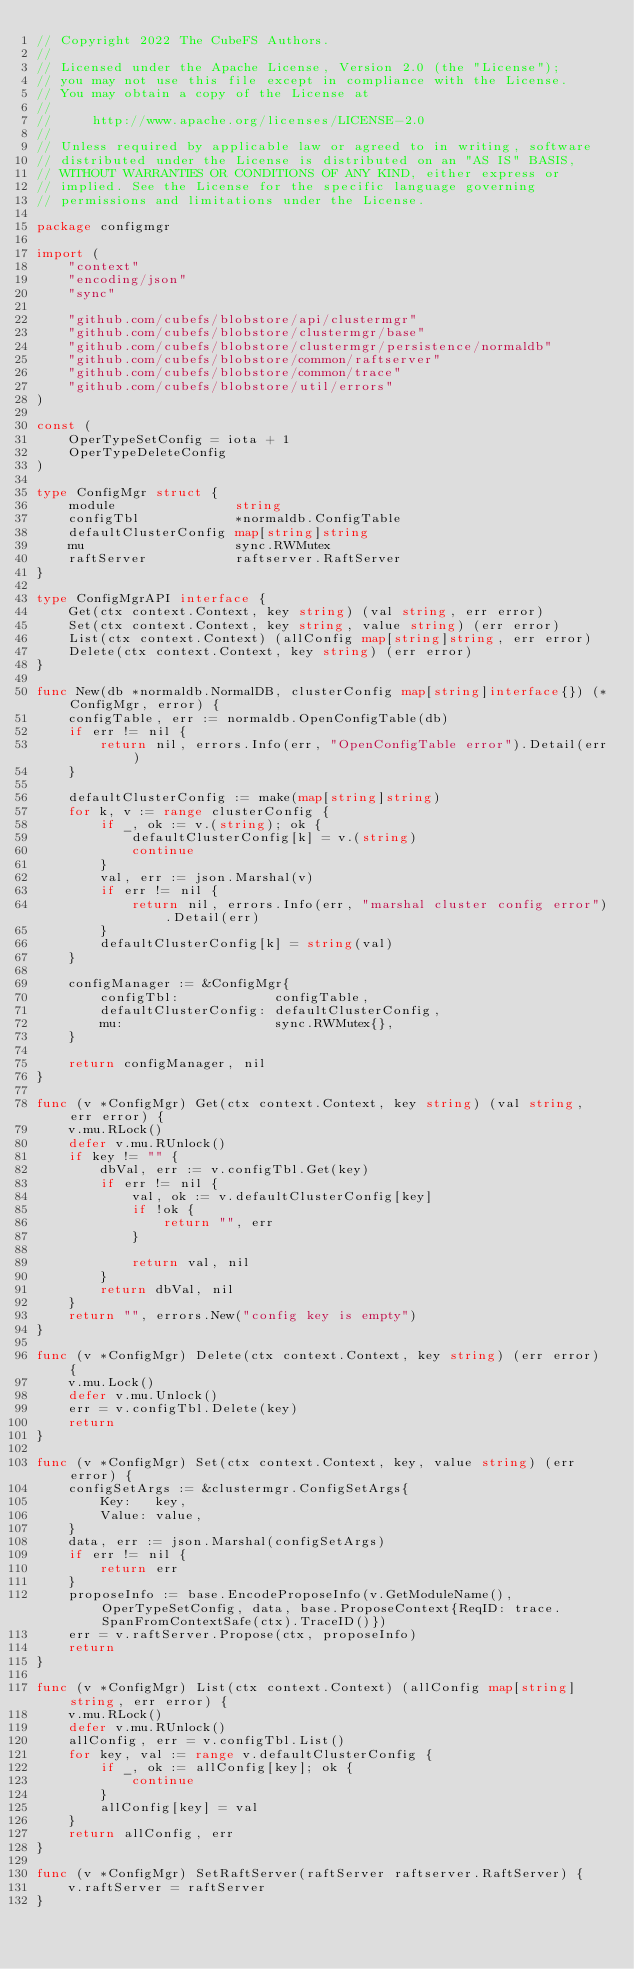Convert code to text. <code><loc_0><loc_0><loc_500><loc_500><_Go_>// Copyright 2022 The CubeFS Authors.
//
// Licensed under the Apache License, Version 2.0 (the "License");
// you may not use this file except in compliance with the License.
// You may obtain a copy of the License at
//
//     http://www.apache.org/licenses/LICENSE-2.0
//
// Unless required by applicable law or agreed to in writing, software
// distributed under the License is distributed on an "AS IS" BASIS,
// WITHOUT WARRANTIES OR CONDITIONS OF ANY KIND, either express or
// implied. See the License for the specific language governing
// permissions and limitations under the License.

package configmgr

import (
	"context"
	"encoding/json"
	"sync"

	"github.com/cubefs/blobstore/api/clustermgr"
	"github.com/cubefs/blobstore/clustermgr/base"
	"github.com/cubefs/blobstore/clustermgr/persistence/normaldb"
	"github.com/cubefs/blobstore/common/raftserver"
	"github.com/cubefs/blobstore/common/trace"
	"github.com/cubefs/blobstore/util/errors"
)

const (
	OperTypeSetConfig = iota + 1
	OperTypeDeleteConfig
)

type ConfigMgr struct {
	module               string
	configTbl            *normaldb.ConfigTable
	defaultClusterConfig map[string]string
	mu                   sync.RWMutex
	raftServer           raftserver.RaftServer
}

type ConfigMgrAPI interface {
	Get(ctx context.Context, key string) (val string, err error)
	Set(ctx context.Context, key string, value string) (err error)
	List(ctx context.Context) (allConfig map[string]string, err error)
	Delete(ctx context.Context, key string) (err error)
}

func New(db *normaldb.NormalDB, clusterConfig map[string]interface{}) (*ConfigMgr, error) {
	configTable, err := normaldb.OpenConfigTable(db)
	if err != nil {
		return nil, errors.Info(err, "OpenConfigTable error").Detail(err)
	}

	defaultClusterConfig := make(map[string]string)
	for k, v := range clusterConfig {
		if _, ok := v.(string); ok {
			defaultClusterConfig[k] = v.(string)
			continue
		}
		val, err := json.Marshal(v)
		if err != nil {
			return nil, errors.Info(err, "marshal cluster config error").Detail(err)
		}
		defaultClusterConfig[k] = string(val)
	}

	configManager := &ConfigMgr{
		configTbl:            configTable,
		defaultClusterConfig: defaultClusterConfig,
		mu:                   sync.RWMutex{},
	}

	return configManager, nil
}

func (v *ConfigMgr) Get(ctx context.Context, key string) (val string, err error) {
	v.mu.RLock()
	defer v.mu.RUnlock()
	if key != "" {
		dbVal, err := v.configTbl.Get(key)
		if err != nil {
			val, ok := v.defaultClusterConfig[key]
			if !ok {
				return "", err
			}

			return val, nil
		}
		return dbVal, nil
	}
	return "", errors.New("config key is empty")
}

func (v *ConfigMgr) Delete(ctx context.Context, key string) (err error) {
	v.mu.Lock()
	defer v.mu.Unlock()
	err = v.configTbl.Delete(key)
	return
}

func (v *ConfigMgr) Set(ctx context.Context, key, value string) (err error) {
	configSetArgs := &clustermgr.ConfigSetArgs{
		Key:   key,
		Value: value,
	}
	data, err := json.Marshal(configSetArgs)
	if err != nil {
		return err
	}
	proposeInfo := base.EncodeProposeInfo(v.GetModuleName(), OperTypeSetConfig, data, base.ProposeContext{ReqID: trace.SpanFromContextSafe(ctx).TraceID()})
	err = v.raftServer.Propose(ctx, proposeInfo)
	return
}

func (v *ConfigMgr) List(ctx context.Context) (allConfig map[string]string, err error) {
	v.mu.RLock()
	defer v.mu.RUnlock()
	allConfig, err = v.configTbl.List()
	for key, val := range v.defaultClusterConfig {
		if _, ok := allConfig[key]; ok {
			continue
		}
		allConfig[key] = val
	}
	return allConfig, err
}

func (v *ConfigMgr) SetRaftServer(raftServer raftserver.RaftServer) {
	v.raftServer = raftServer
}
</code> 